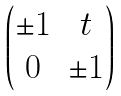<formula> <loc_0><loc_0><loc_500><loc_500>\begin{pmatrix} \pm 1 & t \\ 0 & \pm 1 \end{pmatrix}</formula> 